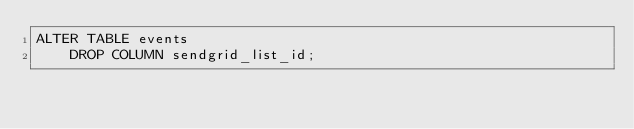Convert code to text. <code><loc_0><loc_0><loc_500><loc_500><_SQL_>ALTER TABLE events
    DROP COLUMN sendgrid_list_id;</code> 